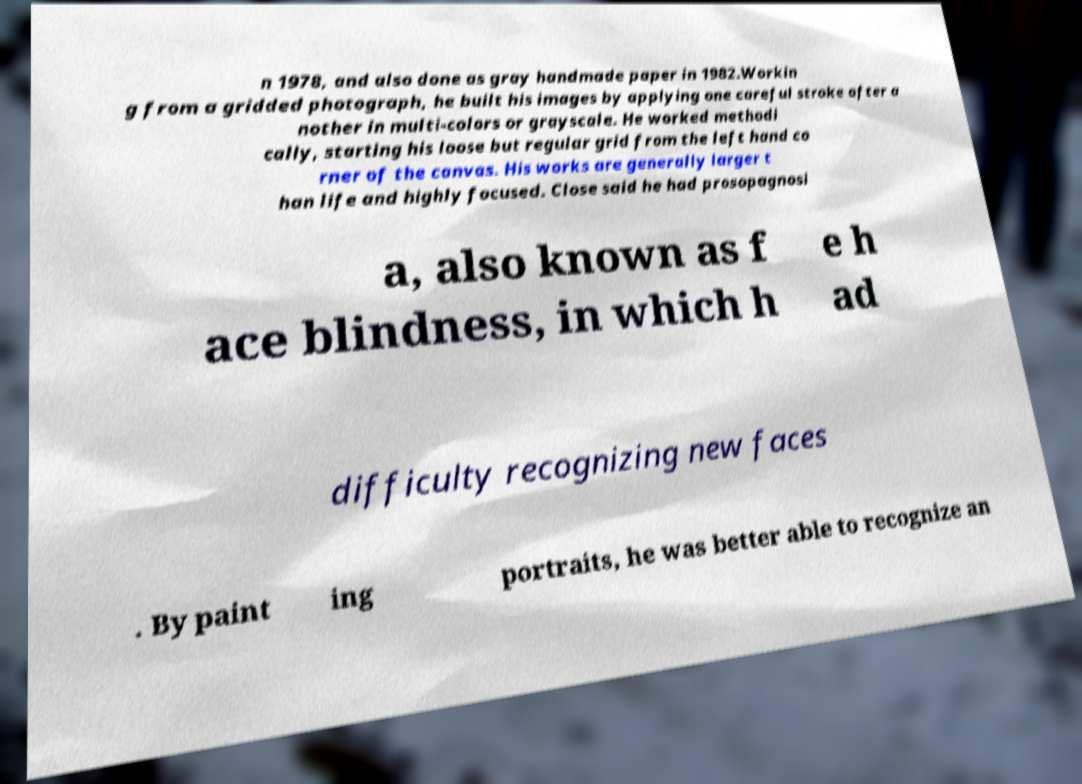Could you assist in decoding the text presented in this image and type it out clearly? n 1978, and also done as gray handmade paper in 1982.Workin g from a gridded photograph, he built his images by applying one careful stroke after a nother in multi-colors or grayscale. He worked methodi cally, starting his loose but regular grid from the left hand co rner of the canvas. His works are generally larger t han life and highly focused. Close said he had prosopagnosi a, also known as f ace blindness, in which h e h ad difficulty recognizing new faces . By paint ing portraits, he was better able to recognize an 